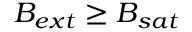Convert formula to latex. <formula><loc_0><loc_0><loc_500><loc_500>B _ { e x t } \geq B _ { s a t }</formula> 